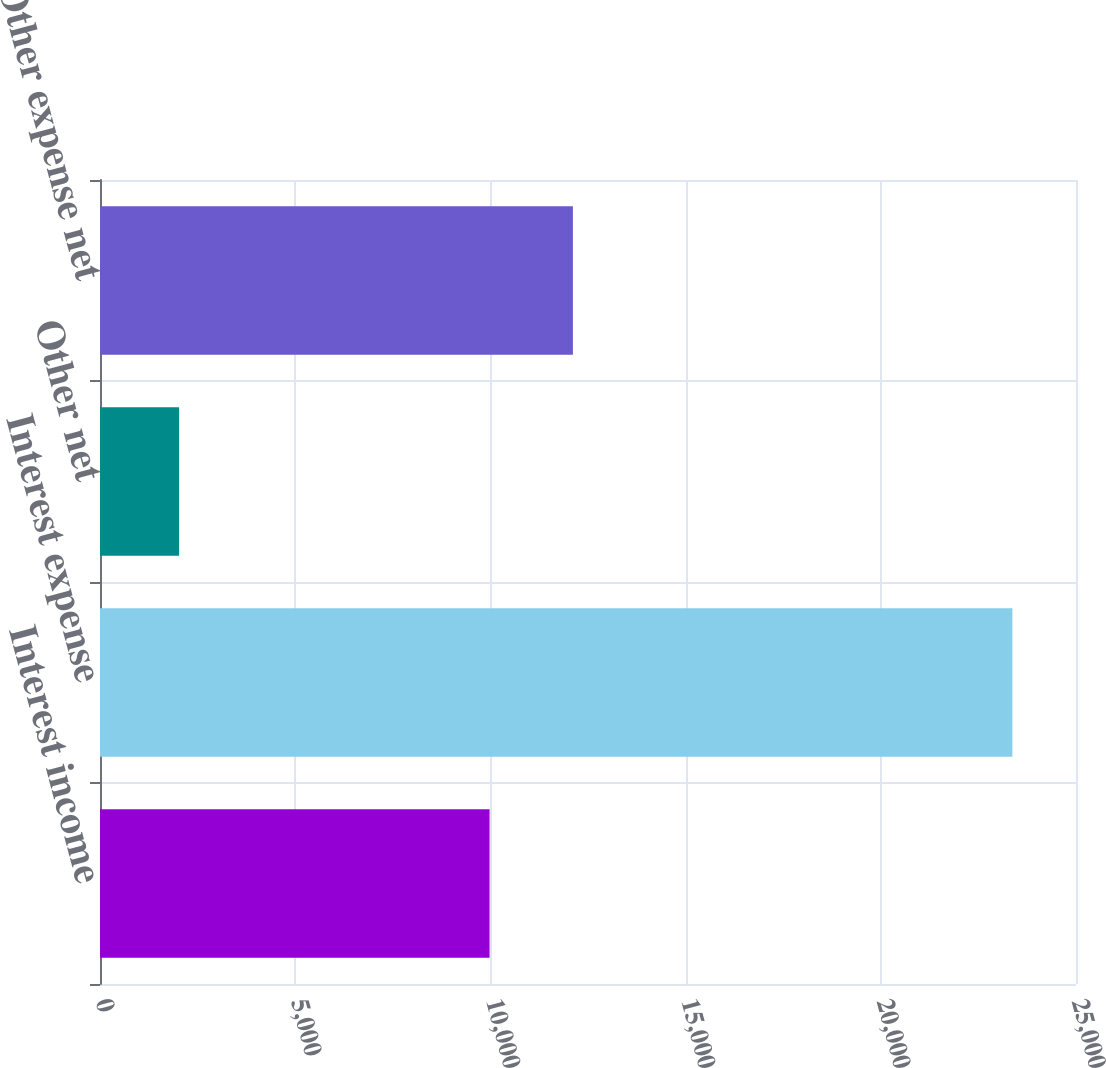Convert chart to OTSL. <chart><loc_0><loc_0><loc_500><loc_500><bar_chart><fcel>Interest income<fcel>Interest expense<fcel>Other net<fcel>Other expense net<nl><fcel>9979<fcel>23370<fcel>2026<fcel>12113.4<nl></chart> 